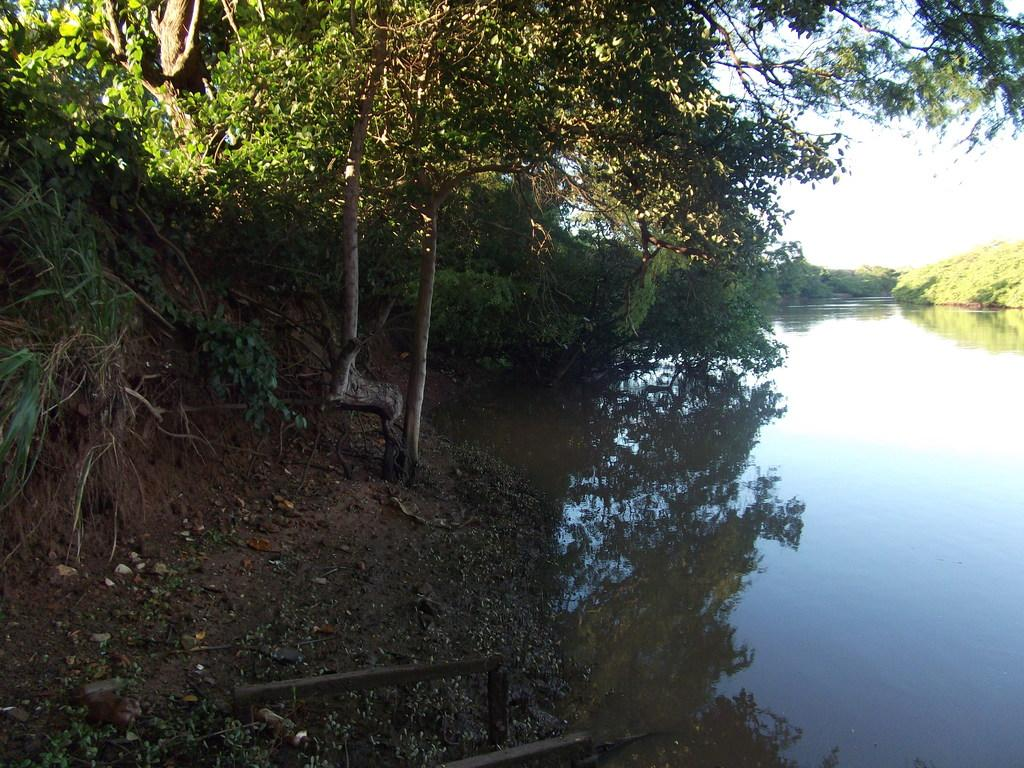What is visible in the image? There is water visible in the image. What type of vegetation can be seen on the sides of the image? There are trees on the sides of the image. What part of the natural environment is visible in the back of the image? The sky is visible in the back of the image. What instrument is being played by the friend in the image? There is no friend or instrument present in the image. How can you increase the amount of water visible in the image? The amount of water visible in the image cannot be increased, as it is a static image. 